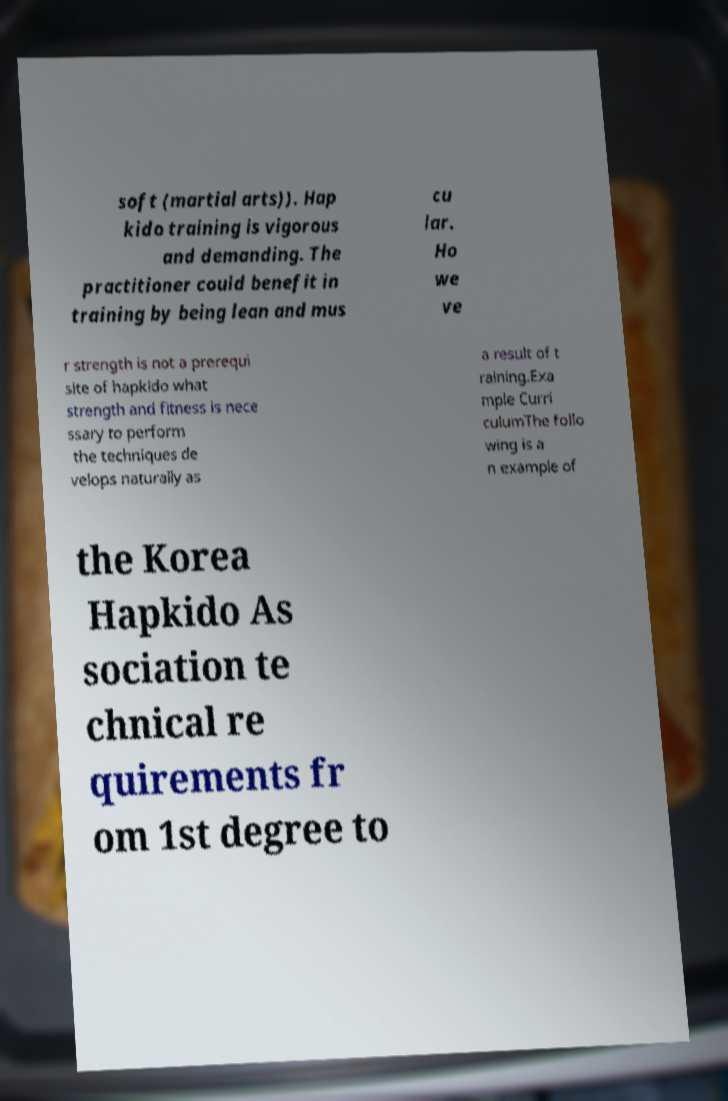What messages or text are displayed in this image? I need them in a readable, typed format. soft (martial arts)). Hap kido training is vigorous and demanding. The practitioner could benefit in training by being lean and mus cu lar. Ho we ve r strength is not a prerequi site of hapkido what strength and fitness is nece ssary to perform the techniques de velops naturally as a result of t raining.Exa mple Curri culumThe follo wing is a n example of the Korea Hapkido As sociation te chnical re quirements fr om 1st degree to 